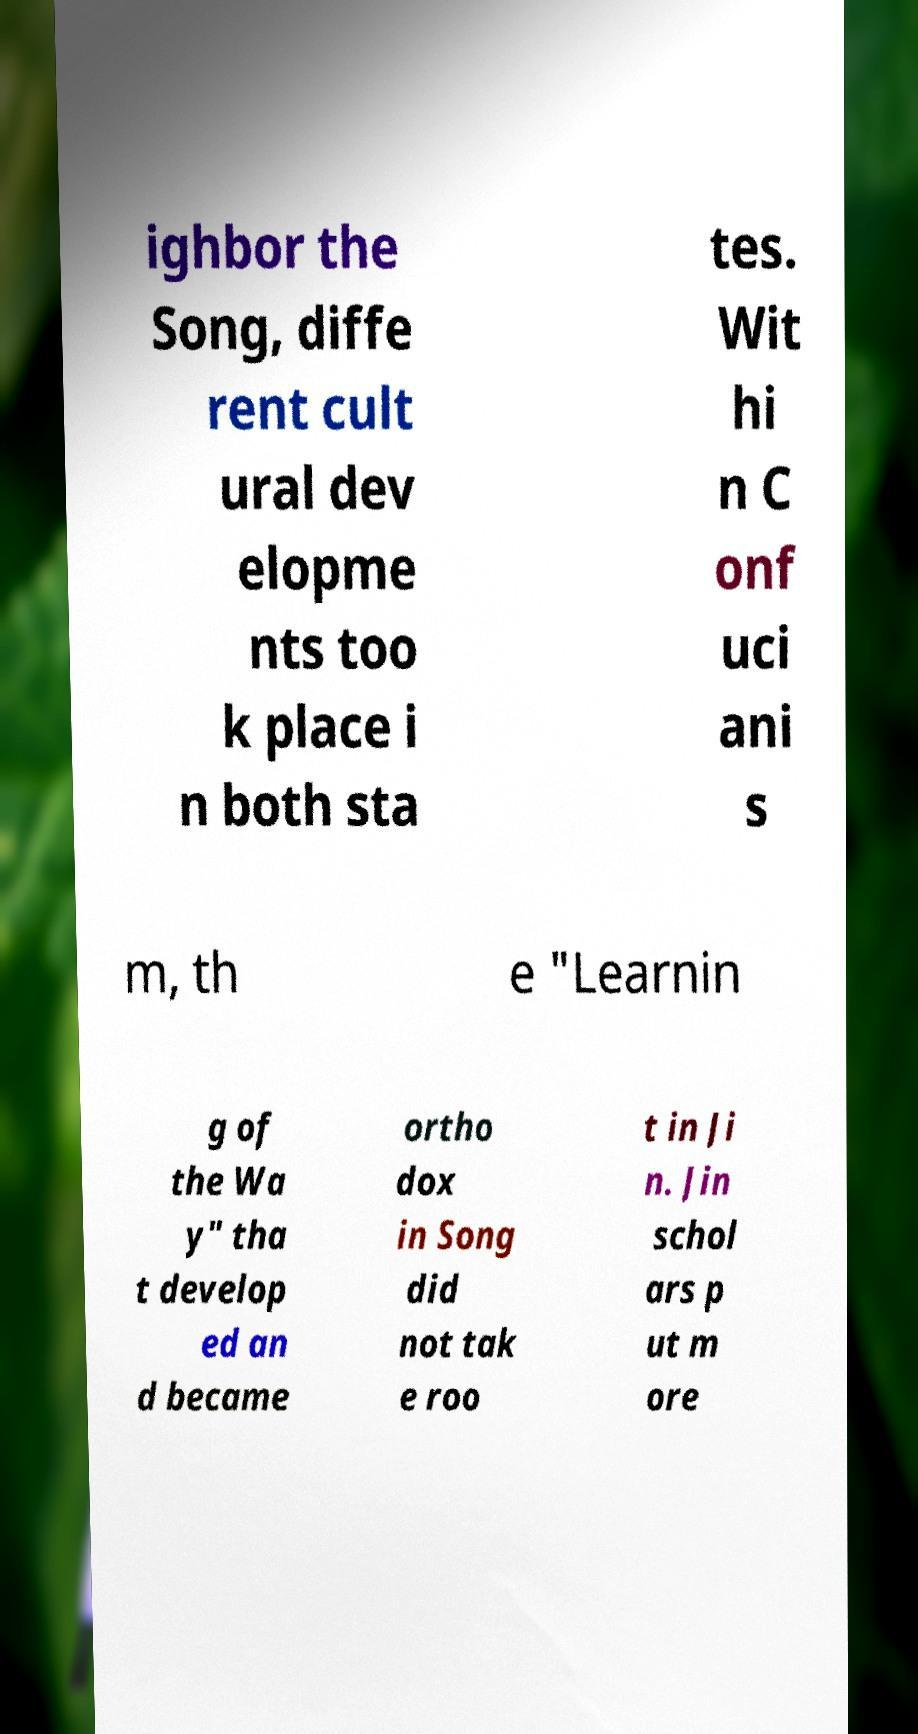There's text embedded in this image that I need extracted. Can you transcribe it verbatim? ighbor the Song, diffe rent cult ural dev elopme nts too k place i n both sta tes. Wit hi n C onf uci ani s m, th e "Learnin g of the Wa y" tha t develop ed an d became ortho dox in Song did not tak e roo t in Ji n. Jin schol ars p ut m ore 